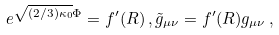<formula> <loc_0><loc_0><loc_500><loc_500>e ^ { \sqrt { ( 2 / 3 ) \kappa _ { 0 } } \Phi } = f ^ { \prime } ( R ) \, , \tilde { g } _ { \mu \nu } = f ^ { \prime } ( R ) g _ { \mu \nu } \, ,</formula> 